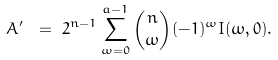Convert formula to latex. <formula><loc_0><loc_0><loc_500><loc_500>A ^ { \prime } \ & = \ 2 ^ { n - 1 } \sum _ { \omega = 0 } ^ { a - 1 } \binom { n } { \omega } ( - 1 ) ^ { \omega } I ( \omega , 0 ) .</formula> 